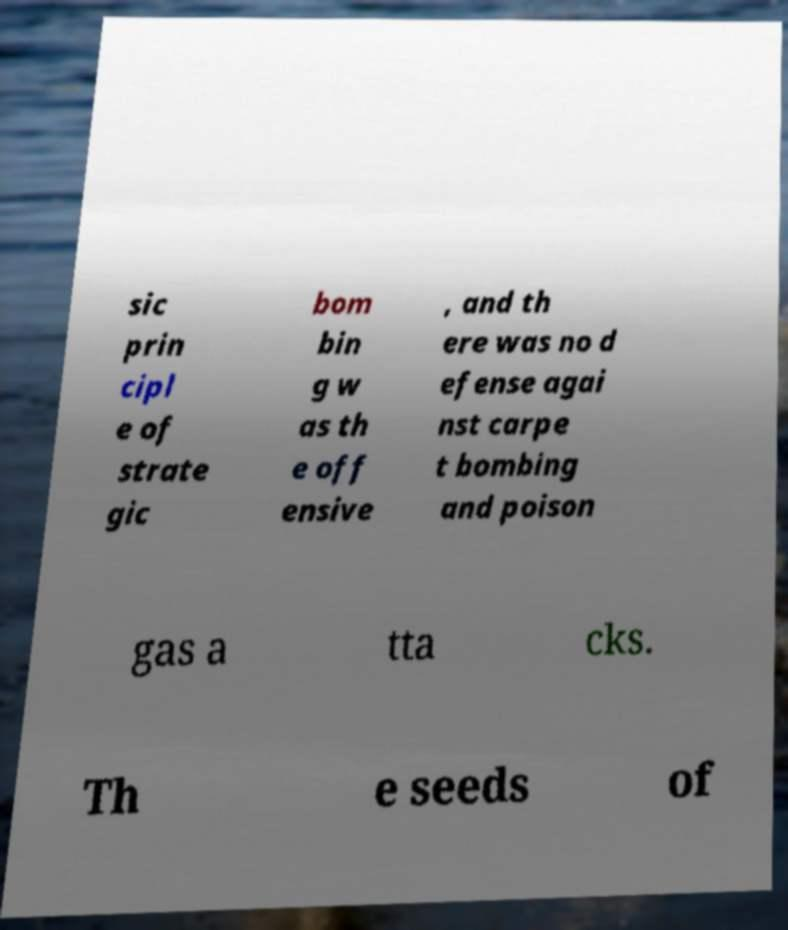Can you read and provide the text displayed in the image?This photo seems to have some interesting text. Can you extract and type it out for me? sic prin cipl e of strate gic bom bin g w as th e off ensive , and th ere was no d efense agai nst carpe t bombing and poison gas a tta cks. Th e seeds of 